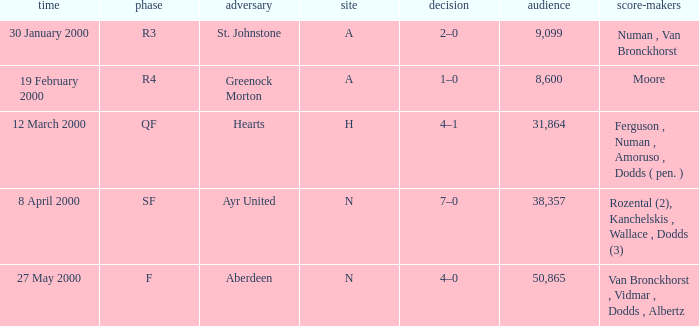Who was on 12 March 2000? Ferguson , Numan , Amoruso , Dodds ( pen. ). 